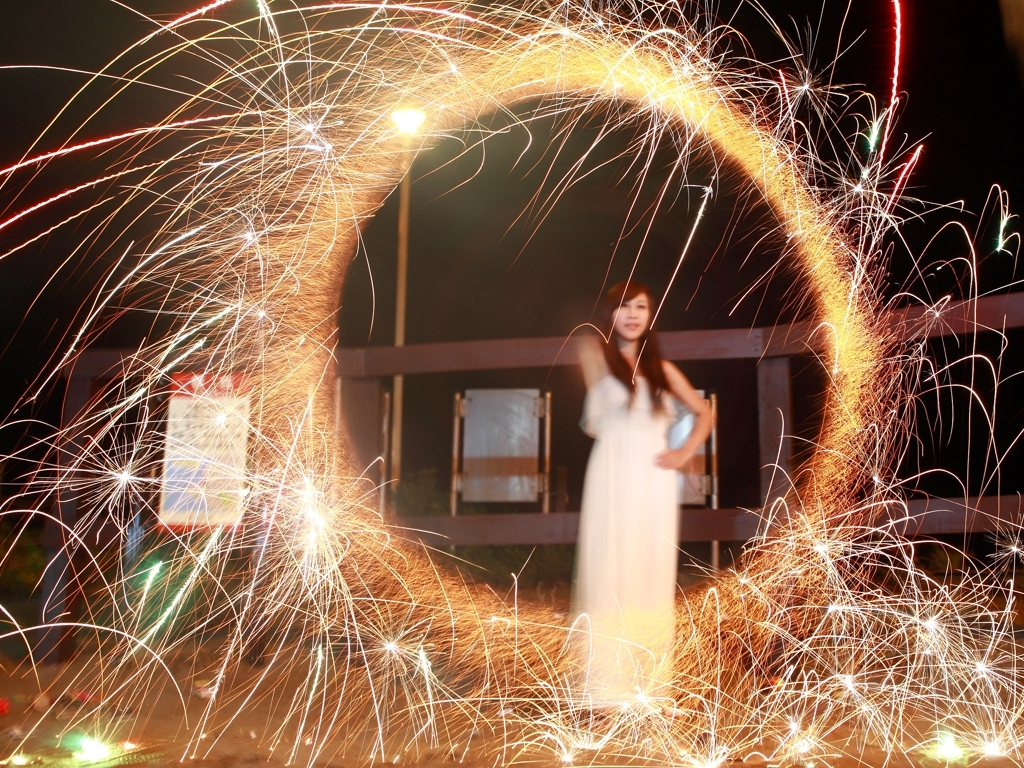Why might this image be significant to the person photographed? This image might hold personal significance due to the occasion it represents, which could be a festival, personal celebration, or public event. It captures a moment of joy and celebration, potentially creating a cherished memory for the person photographed. 